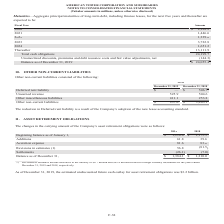According to American Tower Corporation's financial document, As of December 31, 2019, what was the estimated undiscounted future cash outlay for asset retirement obligations? According to the financial document, $3.2 billion. The relevant text states: "e cash outlay for asset retirement obligations was $3.2 billion...." Also, How much were the decreases to the liability included in the revisions in estimates by the company in 2019 and 2018 respectively? The document shows two values: $6.7 million and 49.4 million. From the document: "in estimates include decreases to the liability of $6.7 million and $49.4 million related to foreign currency translation for the years ended a e decr..." Also, What was the accretion expense in 2019? According to the financial document, 81.6 (in millions). The relevant text states: "Accretion expense 81.6 83.6..." Also, can you calculate: What was the change in balance as of December 31 between 2018 and 2019? Based on the calculation: $1,384.1-$1,210.0, the result is 174.1 (in millions). This is based on the information: "Beginning balance as of January 1, $ 1,210.0 $ 1,175.3 Balance as of December 31, $ 1,384.1 $ 1,210.0..." The key data points involved are: 1,210.0, 1,384.1. Also, can you calculate: What is the sum of additions and accretion expense in 2018? Based on the calculation: 39.6+83.6, the result is 123.2 (in millions). This is based on the information: "Accretion expense 81.6 83.6 Additions 61.8 39.6..." The key data points involved are: 39.6, 83.6. Also, can you calculate: What is the percentage change in settlements between 2018 and 2019? To answer this question, I need to perform calculations using the financial data. The calculation is: (-26.1-(-7.0))/-7.0, which equals 272.86 (percentage). This is based on the information: "Settlements (26.1) (7.0) Settlements (26.1) (7.0)..." The key data points involved are: 26.1, 7.0. 